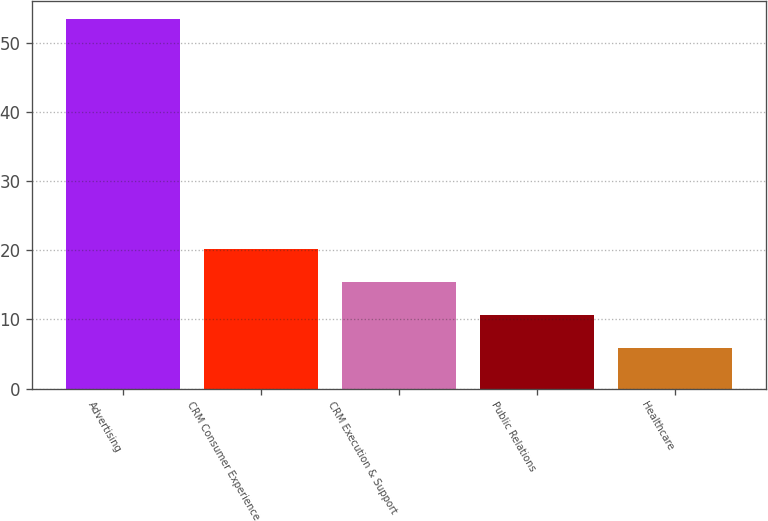Convert chart. <chart><loc_0><loc_0><loc_500><loc_500><bar_chart><fcel>Advertising<fcel>CRM Consumer Experience<fcel>CRM Execution & Support<fcel>Public Relations<fcel>Healthcare<nl><fcel>53.4<fcel>20.15<fcel>15.4<fcel>10.65<fcel>5.9<nl></chart> 